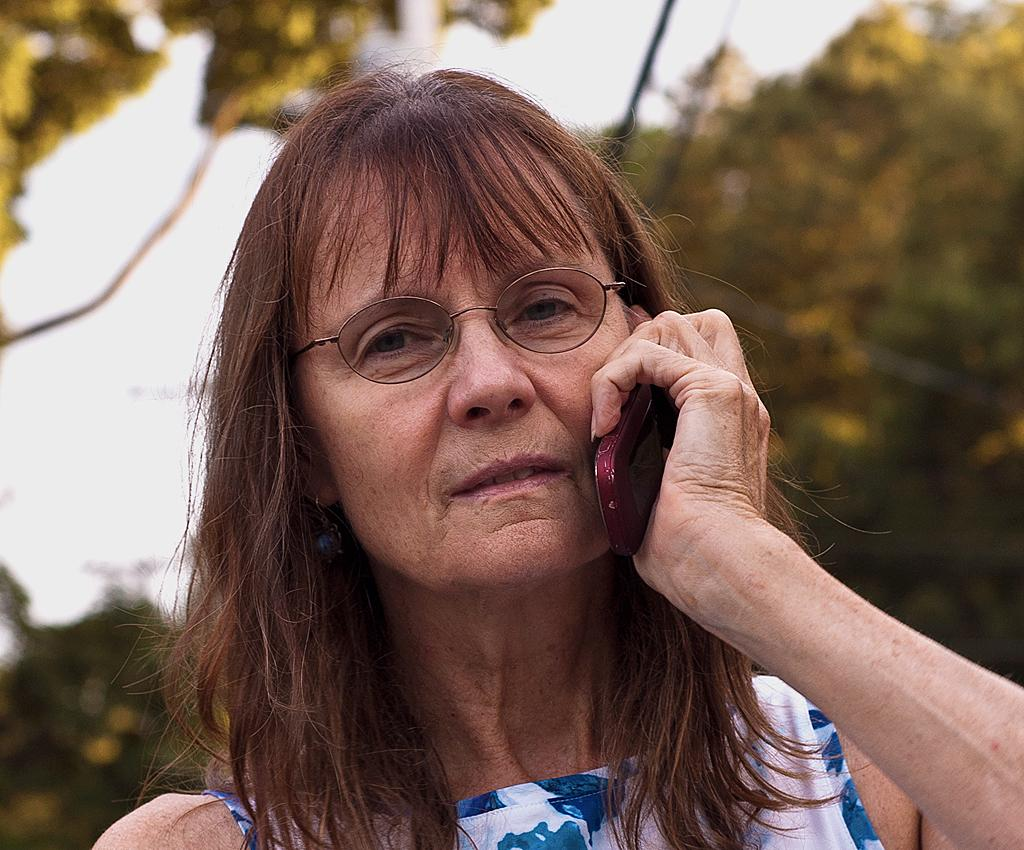What is the main subject of the image? There is a person in the image. What is the person holding in the image? The person is holding a mobile. Can you describe the person's attire? The person is wearing a blue and white color dress. What accessory is the person wearing? The person is wearing specs. What can be seen in the background of the image? There are trees and the sky visible in the background of the image. What type of soap is the person using in the image? There is no soap present in the image; the person is holding a mobile and wearing specs. 